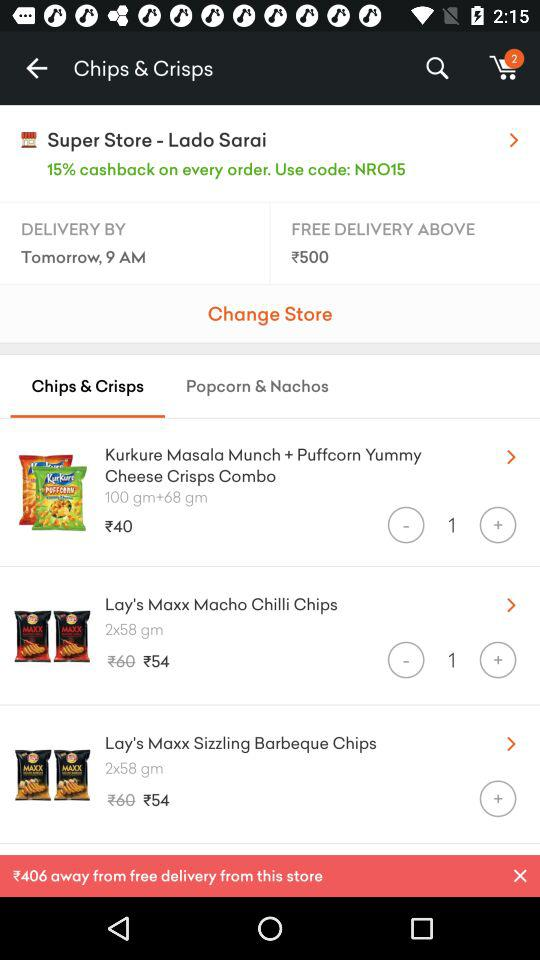What's the cost of "Kurkure"? The cost of "Kurkure" is ₹40. 